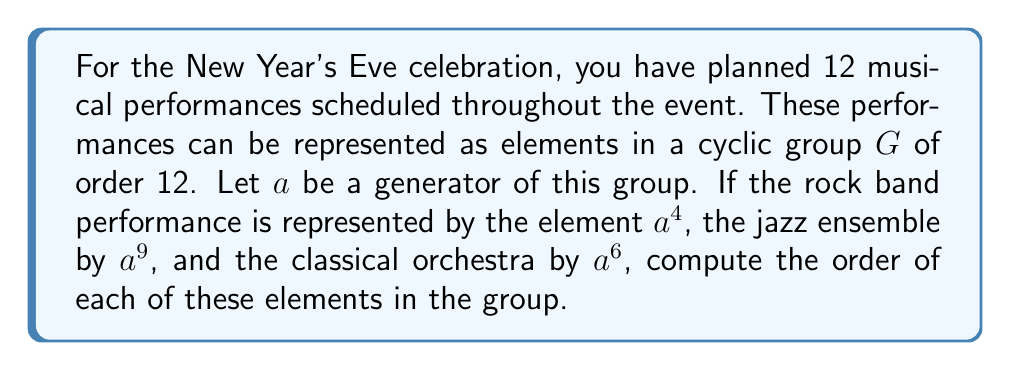Provide a solution to this math problem. To solve this problem, we need to understand the concept of order in a cyclic group and how to compute it. Let's break it down step-by-step:

1) In a cyclic group $G$ of order 12, we have $|G| = 12$. This means that $a^{12} = e$, where $e$ is the identity element.

2) The order of an element $x$ in a group is the smallest positive integer $n$ such that $x^n = e$.

3) For any element $a^k$ in a cyclic group of order $n$, the order of $a^k$ is given by:

   $\text{order}(a^k) = \frac{n}{\gcd(n,k)}$

   where $\gcd$ stands for the greatest common divisor.

4) Now, let's compute the order for each performance:

   a) Rock band ($a^4$):
      $\text{order}(a^4) = \frac{12}{\gcd(12,4)} = \frac{12}{4} = 3$

   b) Jazz ensemble ($a^9$):
      $\text{order}(a^9) = \frac{12}{\gcd(12,9)} = \frac{12}{3} = 4$

   c) Classical orchestra ($a^6$):
      $\text{order}(a^6) = \frac{12}{\gcd(12,6)} = \frac{12}{6} = 2$

5) We can verify these results:
   - $(a^4)^3 = a^{12} = e$
   - $(a^9)^4 = a^{36} = (a^{12})^3 = e^3 = e$
   - $(a^6)^2 = a^{12} = e$

Thus, we have computed the order of each element representing different musical performances in the group.
Answer: The orders of the elements are:
- Rock band ($a^4$): order 3
- Jazz ensemble ($a^9$): order 4
- Classical orchestra ($a^6$): order 2 